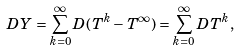<formula> <loc_0><loc_0><loc_500><loc_500>D Y = \sum _ { k = 0 } ^ { \infty } D ( T ^ { k } - T ^ { \infty } ) = \sum _ { k = 0 } ^ { \infty } D T ^ { k } ,</formula> 